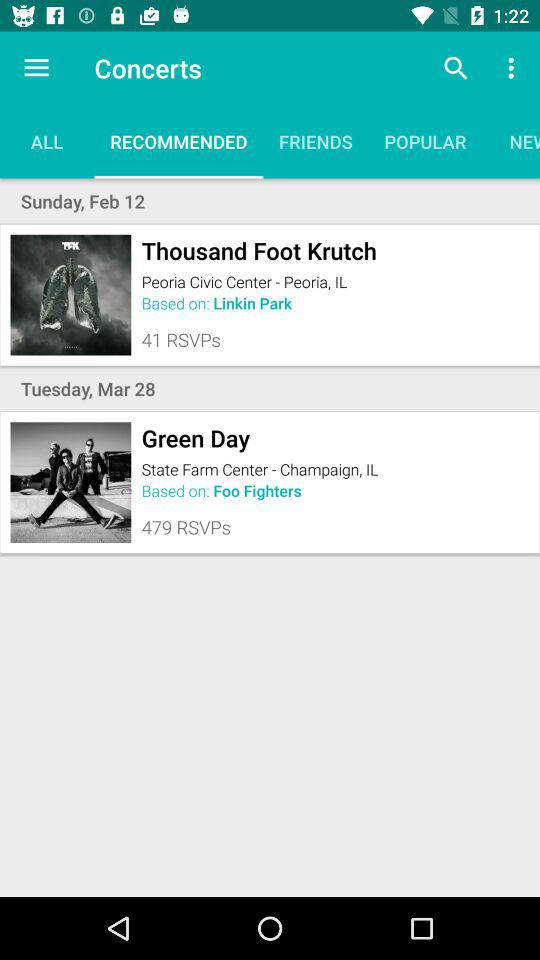How many RSVPs are there for "Green Day"? There are 479 RSVPs. 